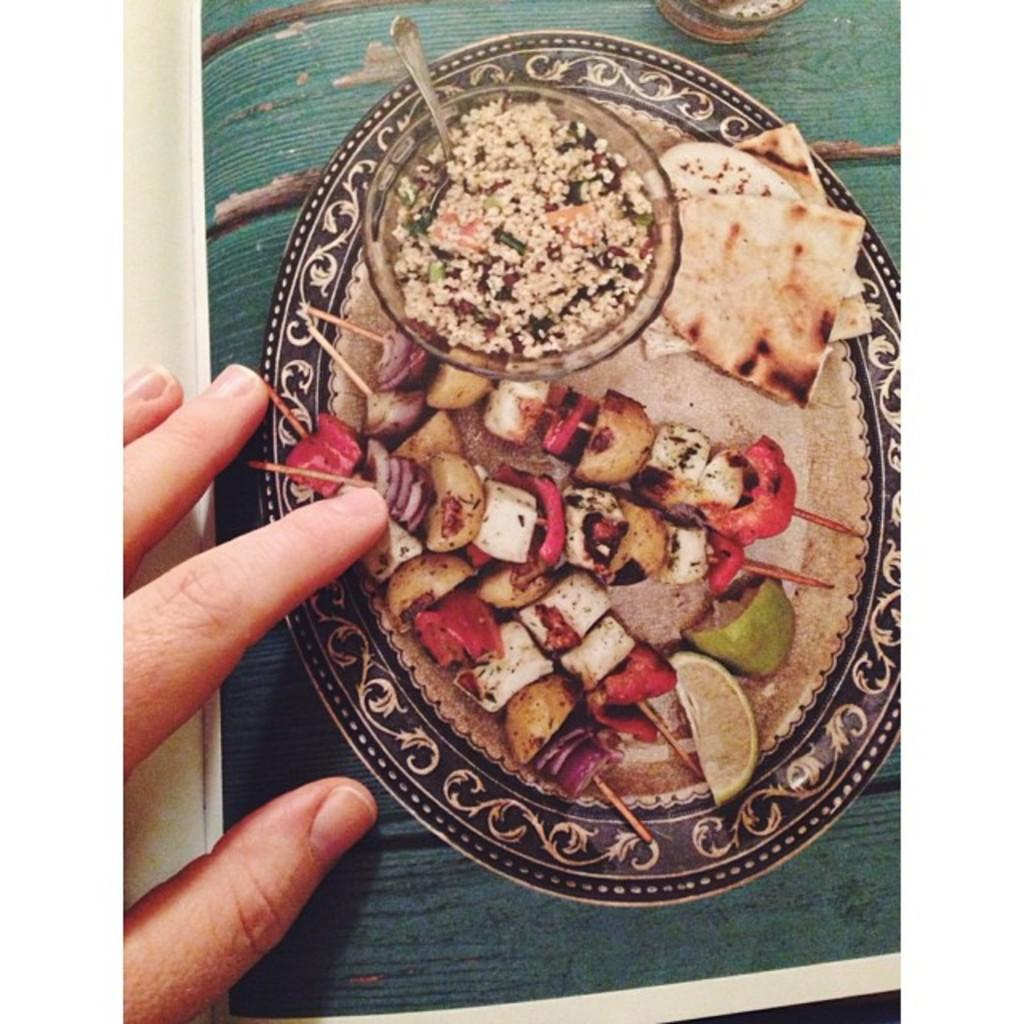What is depicted on the paper in the image? The paper has a plate with food on it. What color is the surface on which the plate is placed? The plate is on a green surface. Whose hand can be seen on the paper? A person's hand is visible on the paper. How many ladybugs are crawling on the plate in the image? There are no ladybugs present in the image; the plate has food on it. 